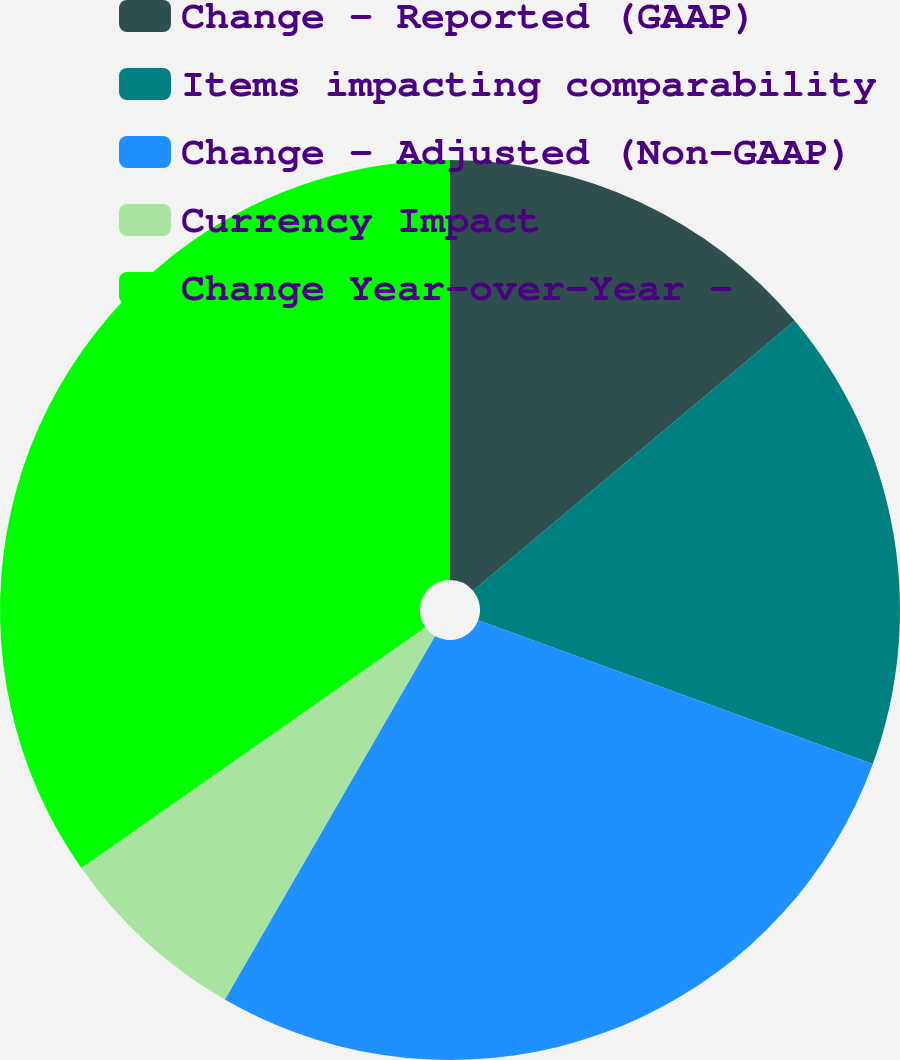Convert chart to OTSL. <chart><loc_0><loc_0><loc_500><loc_500><pie_chart><fcel>Change - Reported (GAAP)<fcel>Items impacting comparability<fcel>Change - Adjusted (Non-GAAP)<fcel>Currency Impact<fcel>Change Year-over-Year -<nl><fcel>13.89%<fcel>16.67%<fcel>27.78%<fcel>6.94%<fcel>34.72%<nl></chart> 